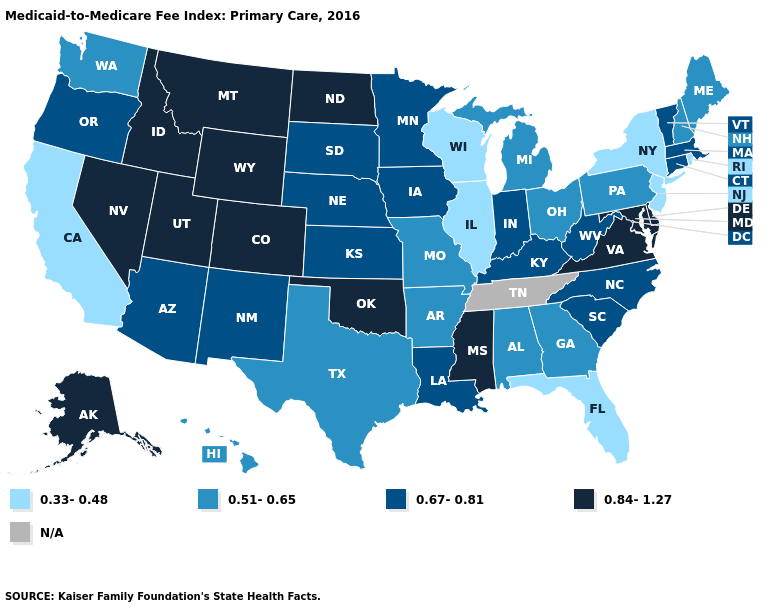Among the states that border Wisconsin , does Illinois have the lowest value?
Quick response, please. Yes. Does Michigan have the lowest value in the MidWest?
Short answer required. No. Name the states that have a value in the range N/A?
Answer briefly. Tennessee. Does the first symbol in the legend represent the smallest category?
Be succinct. Yes. What is the lowest value in the USA?
Answer briefly. 0.33-0.48. What is the highest value in the MidWest ?
Keep it brief. 0.84-1.27. What is the value of Utah?
Give a very brief answer. 0.84-1.27. What is the highest value in states that border Maine?
Be succinct. 0.51-0.65. Does North Dakota have the highest value in the MidWest?
Short answer required. Yes. Does Florida have the lowest value in the South?
Answer briefly. Yes. Name the states that have a value in the range 0.51-0.65?
Short answer required. Alabama, Arkansas, Georgia, Hawaii, Maine, Michigan, Missouri, New Hampshire, Ohio, Pennsylvania, Texas, Washington. Which states have the lowest value in the West?
Answer briefly. California. What is the lowest value in the USA?
Answer briefly. 0.33-0.48. What is the value of North Dakota?
Give a very brief answer. 0.84-1.27. What is the highest value in the USA?
Write a very short answer. 0.84-1.27. 